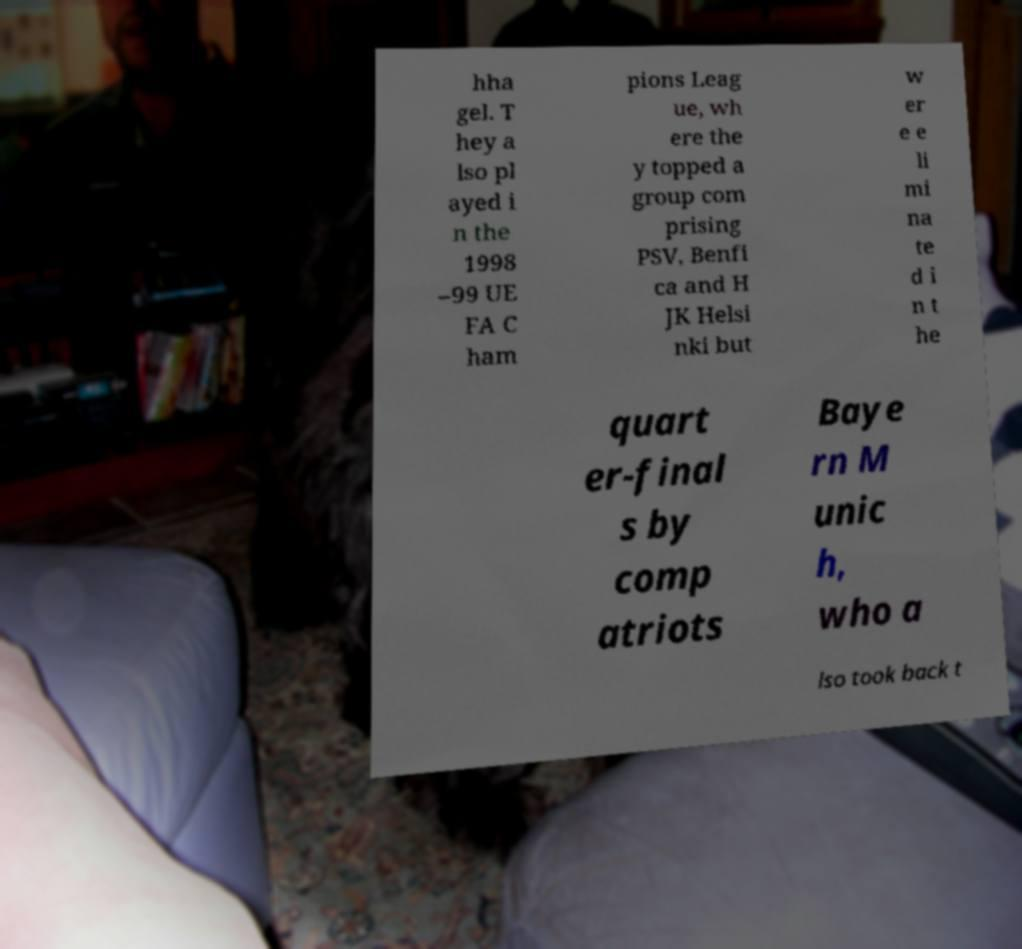Please read and relay the text visible in this image. What does it say? hha gel. T hey a lso pl ayed i n the 1998 –99 UE FA C ham pions Leag ue, wh ere the y topped a group com prising PSV, Benfi ca and H JK Helsi nki but w er e e li mi na te d i n t he quart er-final s by comp atriots Baye rn M unic h, who a lso took back t 